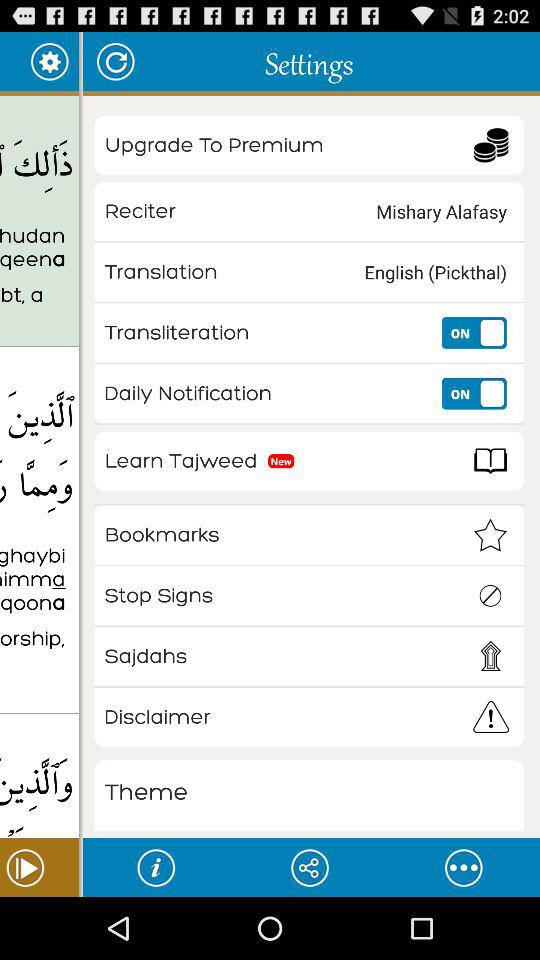What's new in the settings? The new setting is "Learn Tajweed". 